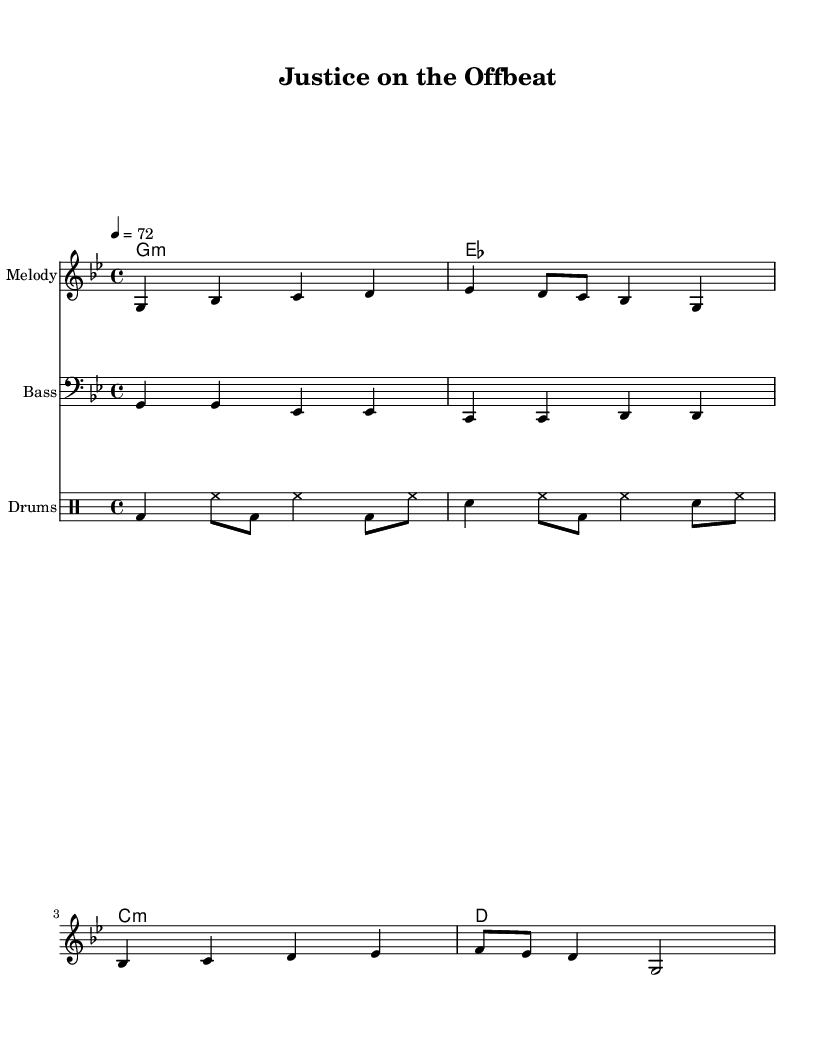What is the key signature of this music? The key signature is G minor, which typically contains two flats: B flat and E flat. It is indicated at the beginning of the staff.
Answer: G minor What is the time signature of this piece? The time signature is shown as 4/4, meaning there are four beats in each measure and the quarter note receives one beat. This is indicated at the beginning of the score.
Answer: 4/4 What is the tempo marking for the piece? The tempo is indicated as 4 = 72, meaning there are 72 beats per minute. This guides the performer on how fast to play the piece.
Answer: 72 How many measures are in the melody part? The melody part has a total of four measures indicated by the bar lines in the staff. Each grouping of notes between the bar lines counts as one measure.
Answer: 4 Which instruments are included in this score? The score includes a melody staff, a bass staff, and a drum staff, indicating the various parts that will be played together in the arrangement.
Answer: Melody, Bass, Drums What theme does the verse address in this music? The verse discusses ethical dilemmas and moral philosophy, as it mentions "the court of life" and the role of individuals in judging right from wrong. This reflects a central theme typical in reggae music focusing on social issues.
Answer: Justice 